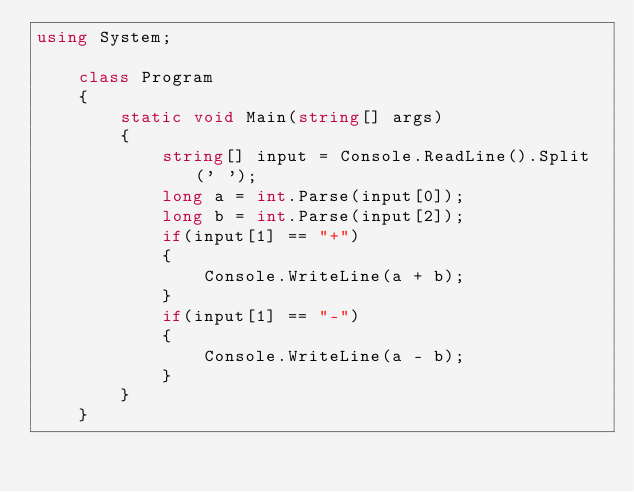<code> <loc_0><loc_0><loc_500><loc_500><_C#_>using System;

    class Program
    {
        static void Main(string[] args)
        {
            string[] input = Console.ReadLine().Split(' ');
            long a = int.Parse(input[0]);
            long b = int.Parse(input[2]);
            if(input[1] == "+")
            {
                Console.WriteLine(a + b);
            }
            if(input[1] == "-")
            {
                Console.WriteLine(a - b);
            }
        }
    }</code> 